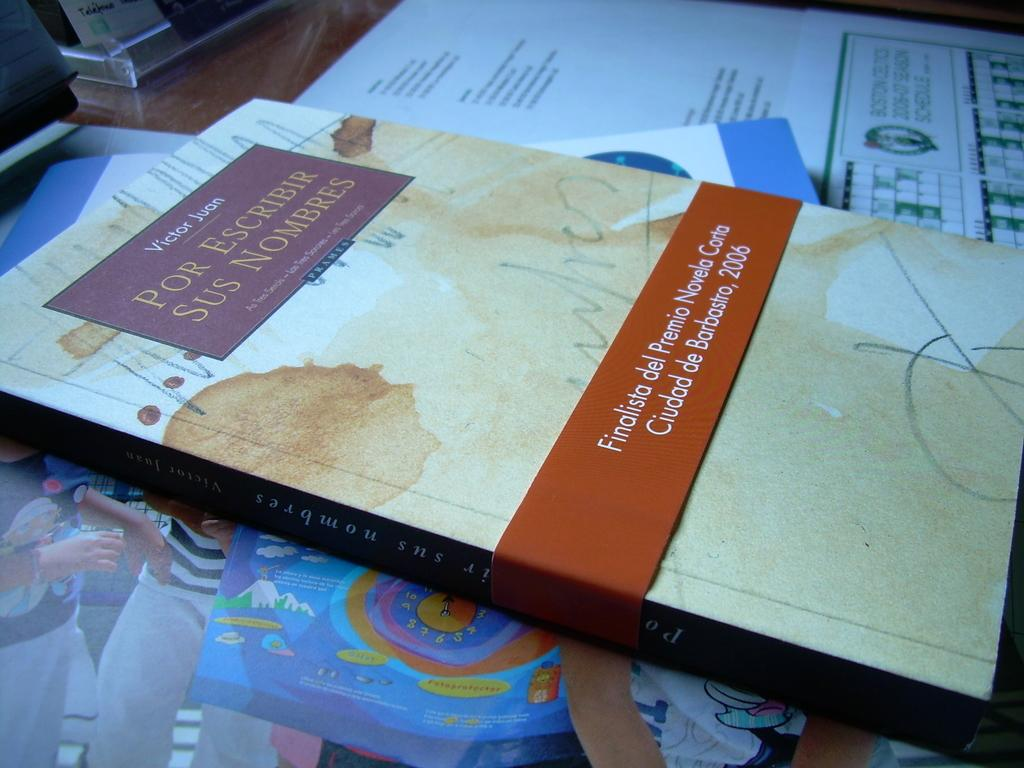<image>
Write a terse but informative summary of the picture. a book that says 'por escribir sus nombres' on the top of it 